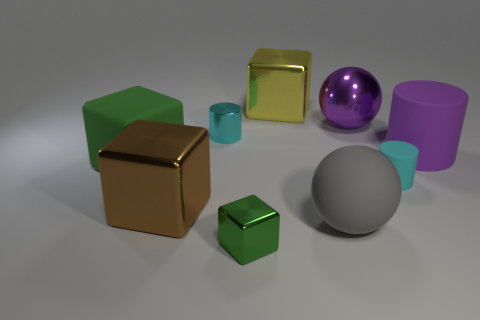Subtract 1 cubes. How many cubes are left? 3 Add 1 large cylinders. How many objects exist? 10 Subtract all cylinders. How many objects are left? 6 Add 3 big yellow shiny cylinders. How many big yellow shiny cylinders exist? 3 Subtract 2 cyan cylinders. How many objects are left? 7 Subtract all gray rubber blocks. Subtract all big brown metallic cubes. How many objects are left? 8 Add 1 big spheres. How many big spheres are left? 3 